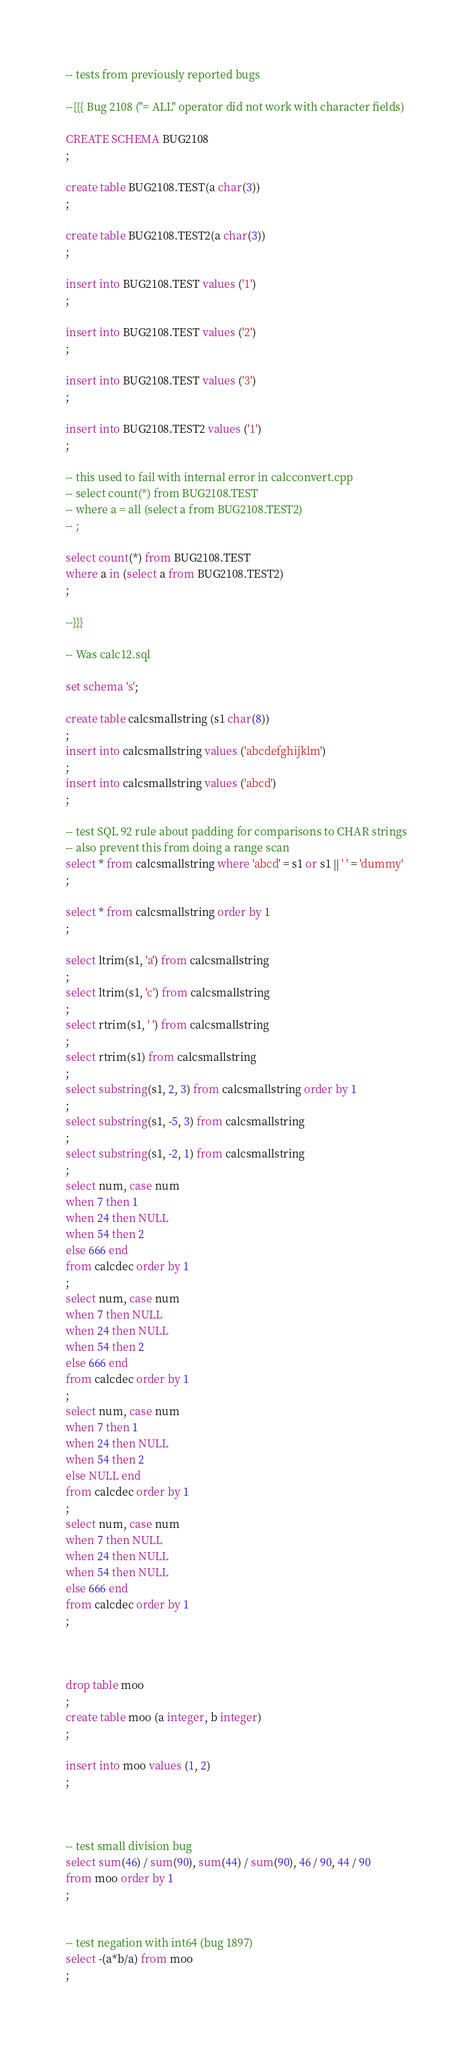<code> <loc_0><loc_0><loc_500><loc_500><_SQL_>-- tests from previously reported bugs

--{{{ Bug 2108 ("= ALL" operator did not work with character fields)

CREATE SCHEMA BUG2108
;

create table BUG2108.TEST(a char(3))
;

create table BUG2108.TEST2(a char(3))
;

insert into BUG2108.TEST values ('1')
;

insert into BUG2108.TEST values ('2')
;

insert into BUG2108.TEST values ('3')
;

insert into BUG2108.TEST2 values ('1')
;

-- this used to fail with internal error in calcconvert.cpp
-- select count(*) from BUG2108.TEST
-- where a = all (select a from BUG2108.TEST2)
-- ;

select count(*) from BUG2108.TEST
where a in (select a from BUG2108.TEST2)
;

--}}}

-- Was calc12.sql

set schema 's';

create table calcsmallstring (s1 char(8))
;
insert into calcsmallstring values ('abcdefghijklm')
;
insert into calcsmallstring values ('abcd')
;

-- test SQL 92 rule about padding for comparisons to CHAR strings
-- also prevent this from doing a range scan
select * from calcsmallstring where 'abcd' = s1 or s1 || ' ' = 'dummy'
;

select * from calcsmallstring order by 1
;

select ltrim(s1, 'a') from calcsmallstring
;
select ltrim(s1, 'c') from calcsmallstring
;
select rtrim(s1, ' ') from calcsmallstring
;
select rtrim(s1) from calcsmallstring
;
select substring(s1, 2, 3) from calcsmallstring order by 1
;
select substring(s1, -5, 3) from calcsmallstring
;
select substring(s1, -2, 1) from calcsmallstring
;
select num, case num
when 7 then 1
when 24 then NULL
when 54 then 2
else 666 end
from calcdec order by 1
;
select num, case num
when 7 then NULL
when 24 then NULL
when 54 then 2
else 666 end
from calcdec order by 1
;
select num, case num
when 7 then 1
when 24 then NULL
when 54 then 2
else NULL end
from calcdec order by 1
;
select num, case num
when 7 then NULL
when 24 then NULL
when 54 then NULL
else 666 end
from calcdec order by 1
;



drop table moo
;
create table moo (a integer, b integer)
;

insert into moo values (1, 2)
;



-- test small division bug
select sum(46) / sum(90), sum(44) / sum(90), 46 / 90, 44 / 90
from moo order by 1
;


-- test negation with int64 (bug 1897)
select -(a*b/a) from moo
;
</code> 